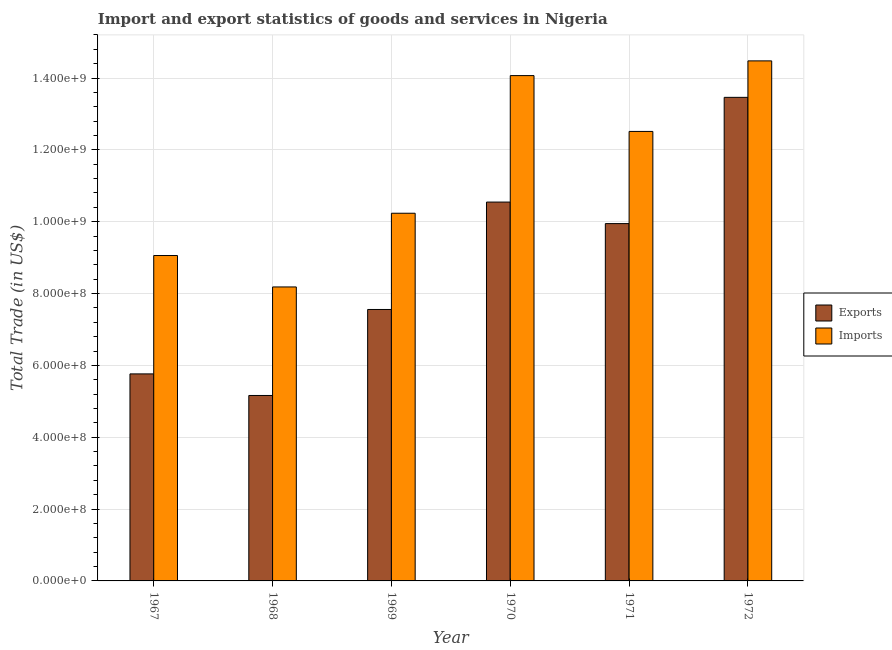How many different coloured bars are there?
Provide a succinct answer. 2. How many groups of bars are there?
Provide a short and direct response. 6. Are the number of bars on each tick of the X-axis equal?
Provide a succinct answer. Yes. How many bars are there on the 6th tick from the right?
Offer a very short reply. 2. What is the label of the 1st group of bars from the left?
Make the answer very short. 1967. What is the export of goods and services in 1970?
Keep it short and to the point. 1.05e+09. Across all years, what is the maximum imports of goods and services?
Make the answer very short. 1.45e+09. Across all years, what is the minimum export of goods and services?
Your response must be concise. 5.16e+08. In which year was the export of goods and services maximum?
Give a very brief answer. 1972. In which year was the export of goods and services minimum?
Ensure brevity in your answer.  1968. What is the total imports of goods and services in the graph?
Your response must be concise. 6.85e+09. What is the difference between the imports of goods and services in 1967 and that in 1968?
Give a very brief answer. 8.75e+07. What is the difference between the imports of goods and services in 1971 and the export of goods and services in 1969?
Keep it short and to the point. 2.28e+08. What is the average imports of goods and services per year?
Provide a short and direct response. 1.14e+09. In how many years, is the export of goods and services greater than 1280000000 US$?
Provide a succinct answer. 1. What is the ratio of the imports of goods and services in 1968 to that in 1970?
Provide a succinct answer. 0.58. Is the imports of goods and services in 1970 less than that in 1971?
Offer a very short reply. No. Is the difference between the imports of goods and services in 1968 and 1972 greater than the difference between the export of goods and services in 1968 and 1972?
Provide a succinct answer. No. What is the difference between the highest and the second highest export of goods and services?
Offer a terse response. 2.92e+08. What is the difference between the highest and the lowest imports of goods and services?
Offer a very short reply. 6.29e+08. In how many years, is the imports of goods and services greater than the average imports of goods and services taken over all years?
Keep it short and to the point. 3. Is the sum of the export of goods and services in 1968 and 1969 greater than the maximum imports of goods and services across all years?
Offer a terse response. No. What does the 2nd bar from the left in 1972 represents?
Offer a terse response. Imports. What does the 1st bar from the right in 1968 represents?
Your response must be concise. Imports. Are all the bars in the graph horizontal?
Offer a terse response. No. What is the difference between two consecutive major ticks on the Y-axis?
Ensure brevity in your answer.  2.00e+08. Does the graph contain grids?
Offer a terse response. Yes. What is the title of the graph?
Make the answer very short. Import and export statistics of goods and services in Nigeria. Does "Broad money growth" appear as one of the legend labels in the graph?
Provide a short and direct response. No. What is the label or title of the Y-axis?
Provide a short and direct response. Total Trade (in US$). What is the Total Trade (in US$) in Exports in 1967?
Offer a terse response. 5.76e+08. What is the Total Trade (in US$) of Imports in 1967?
Provide a succinct answer. 9.06e+08. What is the Total Trade (in US$) of Exports in 1968?
Offer a terse response. 5.16e+08. What is the Total Trade (in US$) in Imports in 1968?
Ensure brevity in your answer.  8.18e+08. What is the Total Trade (in US$) of Exports in 1969?
Keep it short and to the point. 7.56e+08. What is the Total Trade (in US$) in Imports in 1969?
Ensure brevity in your answer.  1.02e+09. What is the Total Trade (in US$) of Exports in 1970?
Provide a succinct answer. 1.05e+09. What is the Total Trade (in US$) of Imports in 1970?
Your response must be concise. 1.41e+09. What is the Total Trade (in US$) in Exports in 1971?
Your response must be concise. 9.95e+08. What is the Total Trade (in US$) of Imports in 1971?
Your response must be concise. 1.25e+09. What is the Total Trade (in US$) in Exports in 1972?
Your answer should be compact. 1.35e+09. What is the Total Trade (in US$) of Imports in 1972?
Provide a short and direct response. 1.45e+09. Across all years, what is the maximum Total Trade (in US$) of Exports?
Your response must be concise. 1.35e+09. Across all years, what is the maximum Total Trade (in US$) of Imports?
Offer a very short reply. 1.45e+09. Across all years, what is the minimum Total Trade (in US$) in Exports?
Make the answer very short. 5.16e+08. Across all years, what is the minimum Total Trade (in US$) of Imports?
Provide a short and direct response. 8.18e+08. What is the total Total Trade (in US$) of Exports in the graph?
Ensure brevity in your answer.  5.24e+09. What is the total Total Trade (in US$) of Imports in the graph?
Give a very brief answer. 6.85e+09. What is the difference between the Total Trade (in US$) of Exports in 1967 and that in 1968?
Keep it short and to the point. 6.01e+07. What is the difference between the Total Trade (in US$) in Imports in 1967 and that in 1968?
Your answer should be very brief. 8.75e+07. What is the difference between the Total Trade (in US$) of Exports in 1967 and that in 1969?
Provide a succinct answer. -1.79e+08. What is the difference between the Total Trade (in US$) of Imports in 1967 and that in 1969?
Offer a very short reply. -1.18e+08. What is the difference between the Total Trade (in US$) in Exports in 1967 and that in 1970?
Keep it short and to the point. -4.78e+08. What is the difference between the Total Trade (in US$) in Imports in 1967 and that in 1970?
Offer a terse response. -5.01e+08. What is the difference between the Total Trade (in US$) in Exports in 1967 and that in 1971?
Make the answer very short. -4.18e+08. What is the difference between the Total Trade (in US$) of Imports in 1967 and that in 1971?
Your response must be concise. -3.45e+08. What is the difference between the Total Trade (in US$) of Exports in 1967 and that in 1972?
Offer a terse response. -7.70e+08. What is the difference between the Total Trade (in US$) of Imports in 1967 and that in 1972?
Offer a very short reply. -5.42e+08. What is the difference between the Total Trade (in US$) in Exports in 1968 and that in 1969?
Make the answer very short. -2.39e+08. What is the difference between the Total Trade (in US$) of Imports in 1968 and that in 1969?
Offer a very short reply. -2.05e+08. What is the difference between the Total Trade (in US$) of Exports in 1968 and that in 1970?
Give a very brief answer. -5.38e+08. What is the difference between the Total Trade (in US$) in Imports in 1968 and that in 1970?
Your answer should be very brief. -5.88e+08. What is the difference between the Total Trade (in US$) in Exports in 1968 and that in 1971?
Keep it short and to the point. -4.78e+08. What is the difference between the Total Trade (in US$) of Imports in 1968 and that in 1971?
Your answer should be very brief. -4.33e+08. What is the difference between the Total Trade (in US$) in Exports in 1968 and that in 1972?
Your answer should be compact. -8.30e+08. What is the difference between the Total Trade (in US$) of Imports in 1968 and that in 1972?
Provide a succinct answer. -6.29e+08. What is the difference between the Total Trade (in US$) in Exports in 1969 and that in 1970?
Your response must be concise. -2.99e+08. What is the difference between the Total Trade (in US$) of Imports in 1969 and that in 1970?
Make the answer very short. -3.83e+08. What is the difference between the Total Trade (in US$) of Exports in 1969 and that in 1971?
Your answer should be very brief. -2.39e+08. What is the difference between the Total Trade (in US$) in Imports in 1969 and that in 1971?
Your response must be concise. -2.28e+08. What is the difference between the Total Trade (in US$) in Exports in 1969 and that in 1972?
Provide a succinct answer. -5.91e+08. What is the difference between the Total Trade (in US$) in Imports in 1969 and that in 1972?
Ensure brevity in your answer.  -4.24e+08. What is the difference between the Total Trade (in US$) of Exports in 1970 and that in 1971?
Ensure brevity in your answer.  6.00e+07. What is the difference between the Total Trade (in US$) of Imports in 1970 and that in 1971?
Provide a succinct answer. 1.55e+08. What is the difference between the Total Trade (in US$) of Exports in 1970 and that in 1972?
Make the answer very short. -2.92e+08. What is the difference between the Total Trade (in US$) in Imports in 1970 and that in 1972?
Ensure brevity in your answer.  -4.10e+07. What is the difference between the Total Trade (in US$) in Exports in 1971 and that in 1972?
Provide a succinct answer. -3.51e+08. What is the difference between the Total Trade (in US$) of Imports in 1971 and that in 1972?
Your answer should be very brief. -1.96e+08. What is the difference between the Total Trade (in US$) in Exports in 1967 and the Total Trade (in US$) in Imports in 1968?
Make the answer very short. -2.42e+08. What is the difference between the Total Trade (in US$) of Exports in 1967 and the Total Trade (in US$) of Imports in 1969?
Provide a short and direct response. -4.47e+08. What is the difference between the Total Trade (in US$) in Exports in 1967 and the Total Trade (in US$) in Imports in 1970?
Provide a short and direct response. -8.30e+08. What is the difference between the Total Trade (in US$) of Exports in 1967 and the Total Trade (in US$) of Imports in 1971?
Make the answer very short. -6.75e+08. What is the difference between the Total Trade (in US$) of Exports in 1967 and the Total Trade (in US$) of Imports in 1972?
Your response must be concise. -8.71e+08. What is the difference between the Total Trade (in US$) of Exports in 1968 and the Total Trade (in US$) of Imports in 1969?
Your answer should be very brief. -5.07e+08. What is the difference between the Total Trade (in US$) of Exports in 1968 and the Total Trade (in US$) of Imports in 1970?
Make the answer very short. -8.91e+08. What is the difference between the Total Trade (in US$) in Exports in 1968 and the Total Trade (in US$) in Imports in 1971?
Keep it short and to the point. -7.35e+08. What is the difference between the Total Trade (in US$) in Exports in 1968 and the Total Trade (in US$) in Imports in 1972?
Give a very brief answer. -9.32e+08. What is the difference between the Total Trade (in US$) of Exports in 1969 and the Total Trade (in US$) of Imports in 1970?
Your response must be concise. -6.51e+08. What is the difference between the Total Trade (in US$) in Exports in 1969 and the Total Trade (in US$) in Imports in 1971?
Give a very brief answer. -4.96e+08. What is the difference between the Total Trade (in US$) in Exports in 1969 and the Total Trade (in US$) in Imports in 1972?
Give a very brief answer. -6.92e+08. What is the difference between the Total Trade (in US$) of Exports in 1970 and the Total Trade (in US$) of Imports in 1971?
Provide a succinct answer. -1.97e+08. What is the difference between the Total Trade (in US$) in Exports in 1970 and the Total Trade (in US$) in Imports in 1972?
Your answer should be compact. -3.93e+08. What is the difference between the Total Trade (in US$) in Exports in 1971 and the Total Trade (in US$) in Imports in 1972?
Keep it short and to the point. -4.53e+08. What is the average Total Trade (in US$) in Exports per year?
Your answer should be very brief. 8.74e+08. What is the average Total Trade (in US$) of Imports per year?
Provide a short and direct response. 1.14e+09. In the year 1967, what is the difference between the Total Trade (in US$) in Exports and Total Trade (in US$) in Imports?
Offer a terse response. -3.30e+08. In the year 1968, what is the difference between the Total Trade (in US$) in Exports and Total Trade (in US$) in Imports?
Give a very brief answer. -3.02e+08. In the year 1969, what is the difference between the Total Trade (in US$) of Exports and Total Trade (in US$) of Imports?
Your answer should be very brief. -2.68e+08. In the year 1970, what is the difference between the Total Trade (in US$) in Exports and Total Trade (in US$) in Imports?
Offer a very short reply. -3.52e+08. In the year 1971, what is the difference between the Total Trade (in US$) of Exports and Total Trade (in US$) of Imports?
Provide a succinct answer. -2.57e+08. In the year 1972, what is the difference between the Total Trade (in US$) of Exports and Total Trade (in US$) of Imports?
Provide a succinct answer. -1.02e+08. What is the ratio of the Total Trade (in US$) of Exports in 1967 to that in 1968?
Make the answer very short. 1.12. What is the ratio of the Total Trade (in US$) in Imports in 1967 to that in 1968?
Offer a very short reply. 1.11. What is the ratio of the Total Trade (in US$) in Exports in 1967 to that in 1969?
Make the answer very short. 0.76. What is the ratio of the Total Trade (in US$) in Imports in 1967 to that in 1969?
Your answer should be compact. 0.89. What is the ratio of the Total Trade (in US$) of Exports in 1967 to that in 1970?
Ensure brevity in your answer.  0.55. What is the ratio of the Total Trade (in US$) of Imports in 1967 to that in 1970?
Provide a short and direct response. 0.64. What is the ratio of the Total Trade (in US$) of Exports in 1967 to that in 1971?
Make the answer very short. 0.58. What is the ratio of the Total Trade (in US$) of Imports in 1967 to that in 1971?
Provide a short and direct response. 0.72. What is the ratio of the Total Trade (in US$) of Exports in 1967 to that in 1972?
Your response must be concise. 0.43. What is the ratio of the Total Trade (in US$) in Imports in 1967 to that in 1972?
Provide a succinct answer. 0.63. What is the ratio of the Total Trade (in US$) of Exports in 1968 to that in 1969?
Offer a terse response. 0.68. What is the ratio of the Total Trade (in US$) in Imports in 1968 to that in 1969?
Provide a succinct answer. 0.8. What is the ratio of the Total Trade (in US$) of Exports in 1968 to that in 1970?
Provide a succinct answer. 0.49. What is the ratio of the Total Trade (in US$) of Imports in 1968 to that in 1970?
Provide a short and direct response. 0.58. What is the ratio of the Total Trade (in US$) in Exports in 1968 to that in 1971?
Give a very brief answer. 0.52. What is the ratio of the Total Trade (in US$) of Imports in 1968 to that in 1971?
Provide a succinct answer. 0.65. What is the ratio of the Total Trade (in US$) of Exports in 1968 to that in 1972?
Your response must be concise. 0.38. What is the ratio of the Total Trade (in US$) in Imports in 1968 to that in 1972?
Offer a very short reply. 0.57. What is the ratio of the Total Trade (in US$) of Exports in 1969 to that in 1970?
Give a very brief answer. 0.72. What is the ratio of the Total Trade (in US$) in Imports in 1969 to that in 1970?
Offer a terse response. 0.73. What is the ratio of the Total Trade (in US$) of Exports in 1969 to that in 1971?
Offer a terse response. 0.76. What is the ratio of the Total Trade (in US$) of Imports in 1969 to that in 1971?
Your answer should be compact. 0.82. What is the ratio of the Total Trade (in US$) of Exports in 1969 to that in 1972?
Make the answer very short. 0.56. What is the ratio of the Total Trade (in US$) in Imports in 1969 to that in 1972?
Your answer should be very brief. 0.71. What is the ratio of the Total Trade (in US$) of Exports in 1970 to that in 1971?
Offer a very short reply. 1.06. What is the ratio of the Total Trade (in US$) in Imports in 1970 to that in 1971?
Your answer should be compact. 1.12. What is the ratio of the Total Trade (in US$) of Exports in 1970 to that in 1972?
Offer a very short reply. 0.78. What is the ratio of the Total Trade (in US$) in Imports in 1970 to that in 1972?
Offer a terse response. 0.97. What is the ratio of the Total Trade (in US$) in Exports in 1971 to that in 1972?
Provide a succinct answer. 0.74. What is the ratio of the Total Trade (in US$) of Imports in 1971 to that in 1972?
Provide a succinct answer. 0.86. What is the difference between the highest and the second highest Total Trade (in US$) in Exports?
Provide a short and direct response. 2.92e+08. What is the difference between the highest and the second highest Total Trade (in US$) of Imports?
Offer a very short reply. 4.10e+07. What is the difference between the highest and the lowest Total Trade (in US$) of Exports?
Provide a short and direct response. 8.30e+08. What is the difference between the highest and the lowest Total Trade (in US$) in Imports?
Provide a succinct answer. 6.29e+08. 